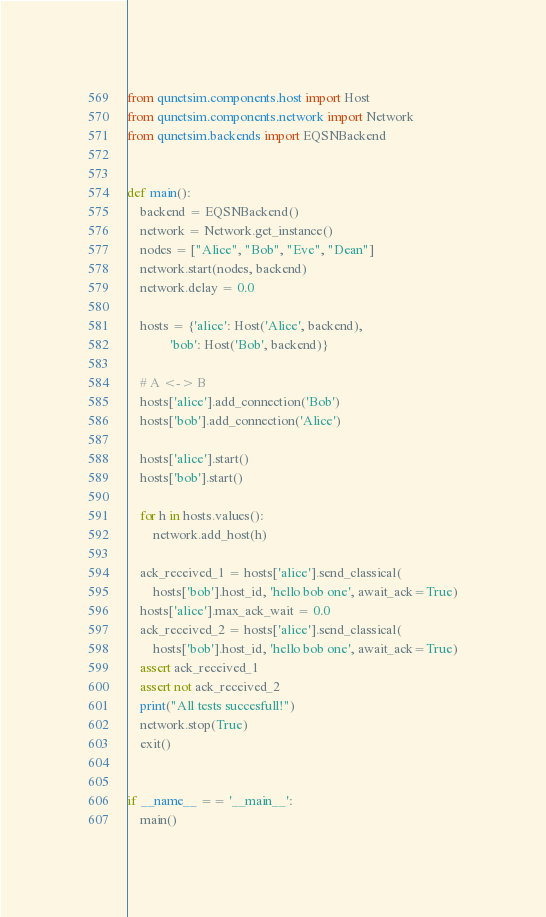<code> <loc_0><loc_0><loc_500><loc_500><_Python_>from qunetsim.components.host import Host
from qunetsim.components.network import Network
from qunetsim.backends import EQSNBackend


def main():
    backend = EQSNBackend()
    network = Network.get_instance()
    nodes = ["Alice", "Bob", "Eve", "Dean"]
    network.start(nodes, backend)
    network.delay = 0.0

    hosts = {'alice': Host('Alice', backend),
             'bob': Host('Bob', backend)}

    # A <-> B
    hosts['alice'].add_connection('Bob')
    hosts['bob'].add_connection('Alice')

    hosts['alice'].start()
    hosts['bob'].start()

    for h in hosts.values():
        network.add_host(h)

    ack_received_1 = hosts['alice'].send_classical(
        hosts['bob'].host_id, 'hello bob one', await_ack=True)
    hosts['alice'].max_ack_wait = 0.0
    ack_received_2 = hosts['alice'].send_classical(
        hosts['bob'].host_id, 'hello bob one', await_ack=True)
    assert ack_received_1
    assert not ack_received_2
    print("All tests succesfull!")
    network.stop(True)
    exit()


if __name__ == '__main__':
    main()
</code> 